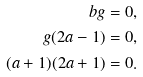Convert formula to latex. <formula><loc_0><loc_0><loc_500><loc_500>b g = 0 , \\ g ( 2 a - 1 ) = 0 , \\ ( a + 1 ) ( 2 a + 1 ) = 0 .</formula> 